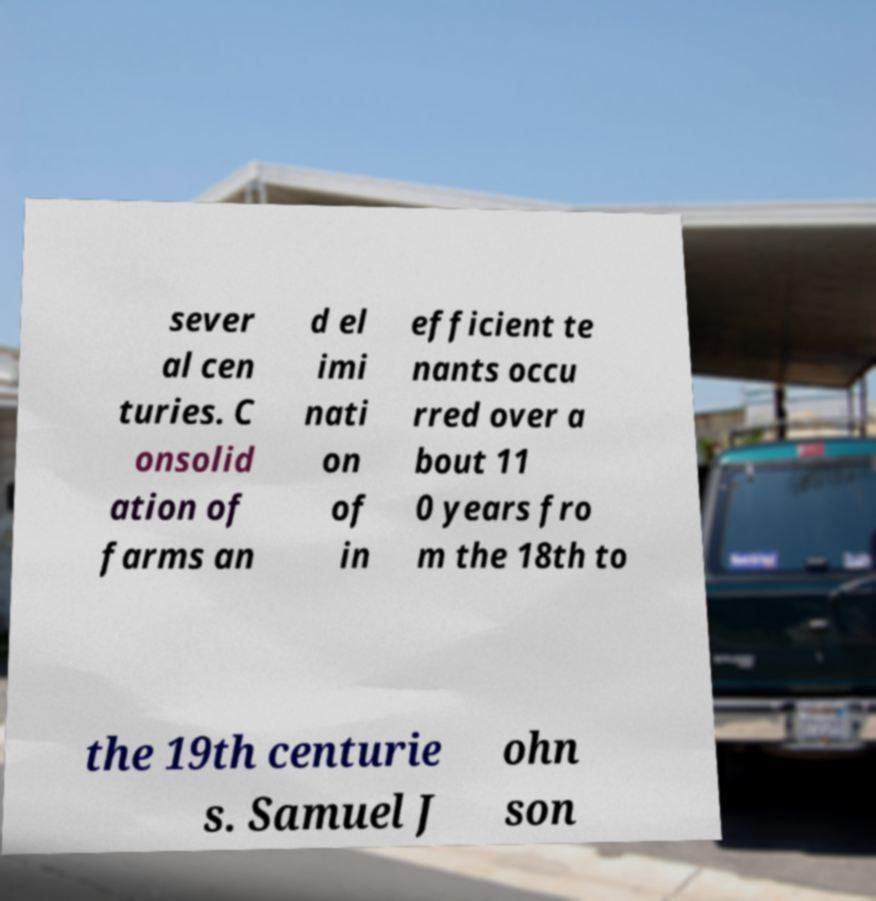What messages or text are displayed in this image? I need them in a readable, typed format. sever al cen turies. C onsolid ation of farms an d el imi nati on of in efficient te nants occu rred over a bout 11 0 years fro m the 18th to the 19th centurie s. Samuel J ohn son 